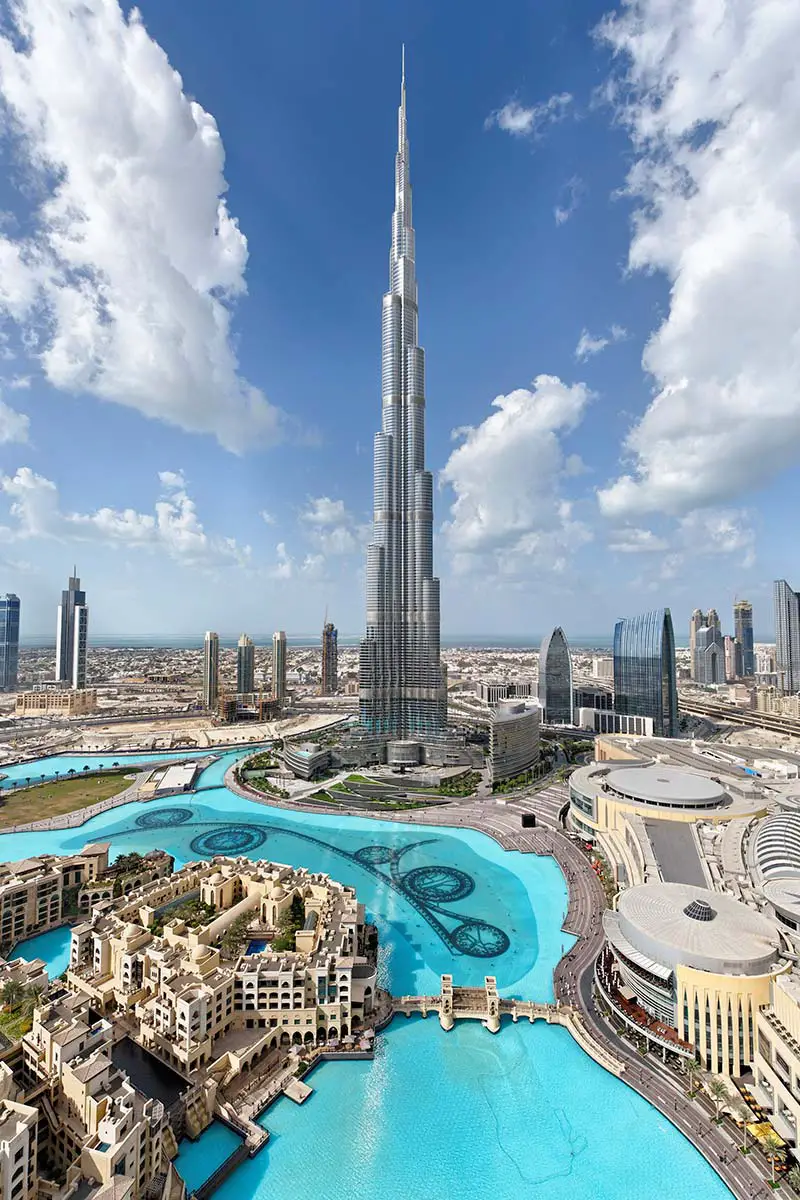What do you think the people in those buildings are doing right now? In the myriad of buildings surrounding the Burj Khalifa, life unfolds in a symphony of activities. Business professionals are likely engaging in meetings, discussing deals that could shape the future. Tourists are possibly marveling at the view from their hotel windows, planning their next adventure in this vibrant city. In residential apartments, families are beginning their day, enjoying the morning sunshine filtering through their windows, while children eagerly prepare for school. Each building is a microcosm of life, contributing to the bustling energy that defines Dubai. 